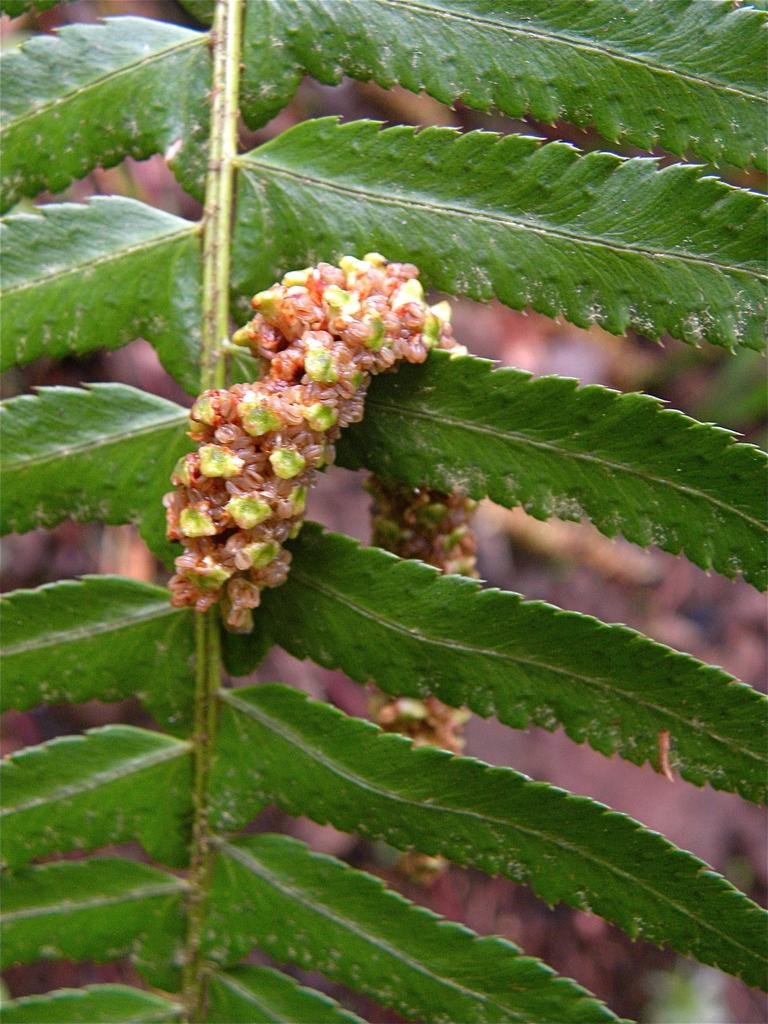What is the main subject of the image? The main subject of the image is a group of leaves. Can you describe the leaves in the image? The leaves are on a stem of a plant. What type of leather can be seen on the drawer in the image? There is no drawer or leather present in the image; it only features a group of leaves on a stem of a plant. 